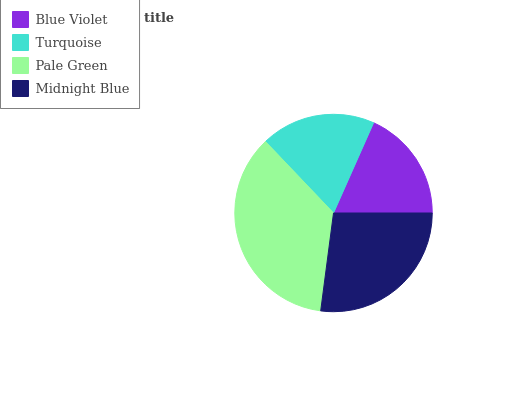Is Blue Violet the minimum?
Answer yes or no. Yes. Is Pale Green the maximum?
Answer yes or no. Yes. Is Turquoise the minimum?
Answer yes or no. No. Is Turquoise the maximum?
Answer yes or no. No. Is Turquoise greater than Blue Violet?
Answer yes or no. Yes. Is Blue Violet less than Turquoise?
Answer yes or no. Yes. Is Blue Violet greater than Turquoise?
Answer yes or no. No. Is Turquoise less than Blue Violet?
Answer yes or no. No. Is Midnight Blue the high median?
Answer yes or no. Yes. Is Turquoise the low median?
Answer yes or no. Yes. Is Turquoise the high median?
Answer yes or no. No. Is Blue Violet the low median?
Answer yes or no. No. 